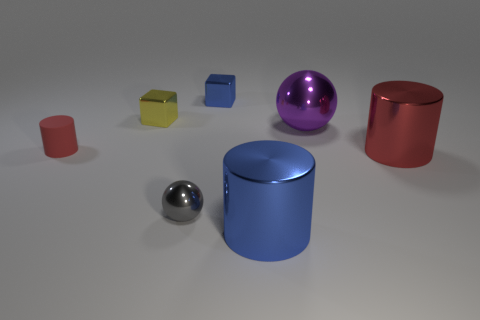Subtract all metallic cylinders. How many cylinders are left? 1 Subtract all blue spheres. How many red cylinders are left? 2 Add 1 big yellow metal cylinders. How many objects exist? 8 Subtract all brown cylinders. Subtract all blue balls. How many cylinders are left? 3 Add 1 small yellow metal cubes. How many small yellow metal cubes exist? 2 Subtract 1 gray spheres. How many objects are left? 6 Subtract all cubes. How many objects are left? 5 Subtract all large blue shiny balls. Subtract all purple balls. How many objects are left? 6 Add 5 red things. How many red things are left? 7 